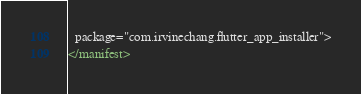Convert code to text. <code><loc_0><loc_0><loc_500><loc_500><_XML_>  package="com.irvinechang.flutter_app_installer">
</manifest>
</code> 